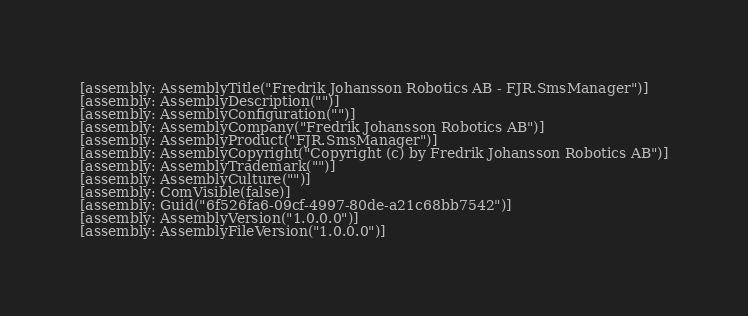Convert code to text. <code><loc_0><loc_0><loc_500><loc_500><_C#_>
[assembly: AssemblyTitle("Fredrik Johansson Robotics AB - FJR.SmsManager")]
[assembly: AssemblyDescription("")]
[assembly: AssemblyConfiguration("")]
[assembly: AssemblyCompany("Fredrik Johansson Robotics AB")]
[assembly: AssemblyProduct("FJR.SmsManager")]
[assembly: AssemblyCopyright("Copyright (c) by Fredrik Johansson Robotics AB")]
[assembly: AssemblyTrademark("")]
[assembly: AssemblyCulture("")]
[assembly: ComVisible(false)]
[assembly: Guid("6f526fa6-09cf-4997-80de-a21c68bb7542")]
[assembly: AssemblyVersion("1.0.0.0")]
[assembly: AssemblyFileVersion("1.0.0.0")]
</code> 